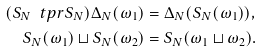Convert formula to latex. <formula><loc_0><loc_0><loc_500><loc_500>( S _ { N } \ t p r S _ { N } ) \Delta _ { N } ( \omega _ { 1 } ) & = \Delta _ { N } ( S _ { N } ( \omega _ { 1 } ) ) , \\ S _ { N } ( \omega _ { 1 } ) \sqcup S _ { N } ( \omega _ { 2 } ) & = S _ { N } ( \omega _ { 1 } \sqcup \omega _ { 2 } ) .</formula> 